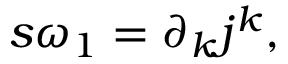Convert formula to latex. <formula><loc_0><loc_0><loc_500><loc_500>s \omega _ { 1 } = \partial _ { k } j ^ { k } ,</formula> 